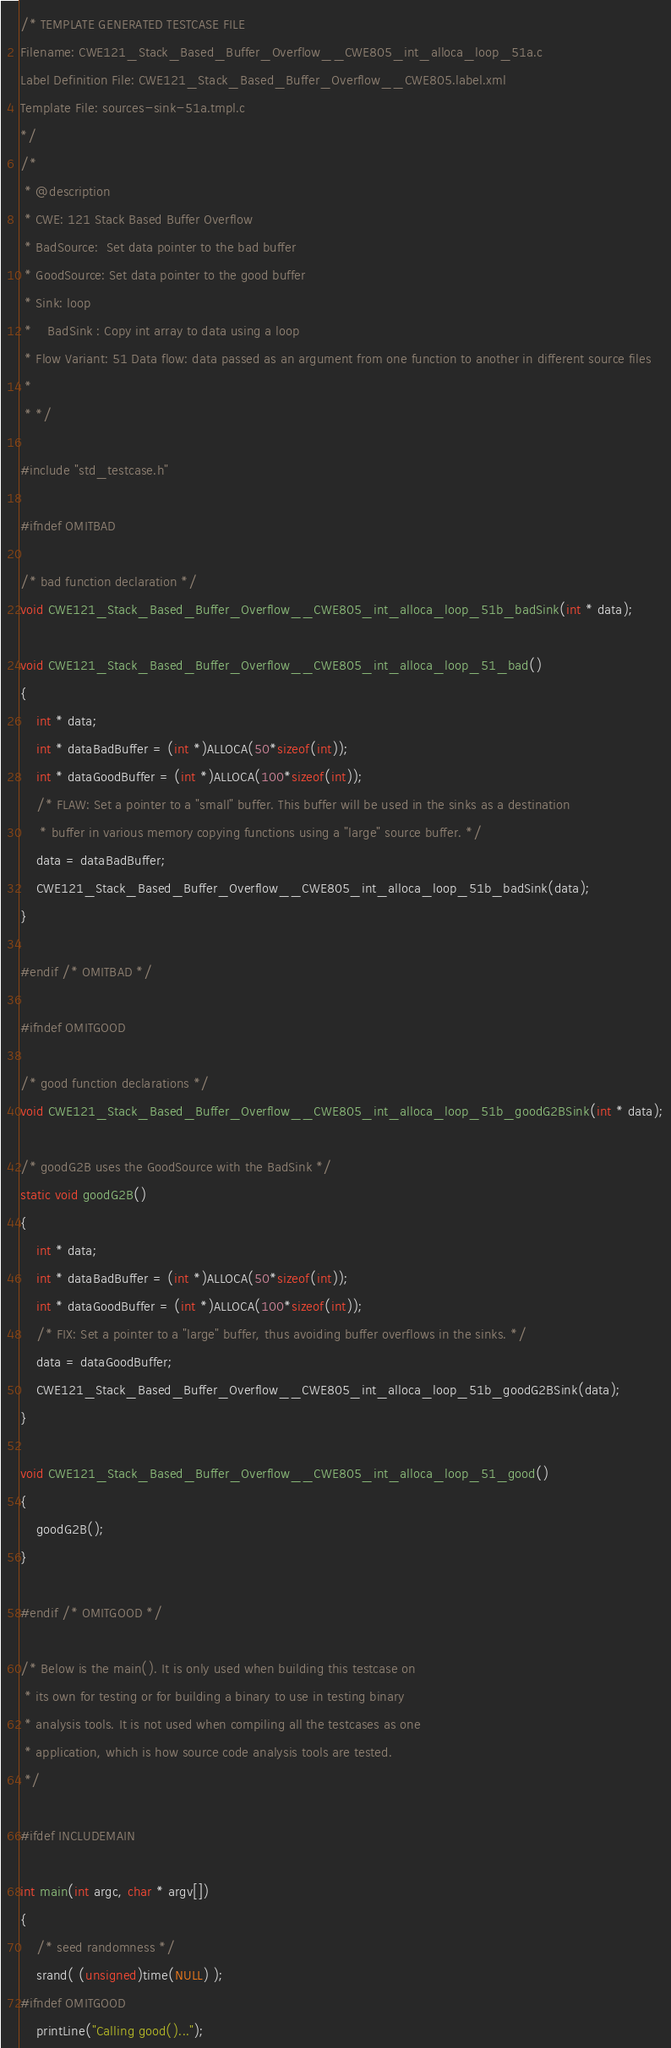Convert code to text. <code><loc_0><loc_0><loc_500><loc_500><_C_>/* TEMPLATE GENERATED TESTCASE FILE
Filename: CWE121_Stack_Based_Buffer_Overflow__CWE805_int_alloca_loop_51a.c
Label Definition File: CWE121_Stack_Based_Buffer_Overflow__CWE805.label.xml
Template File: sources-sink-51a.tmpl.c
*/
/*
 * @description
 * CWE: 121 Stack Based Buffer Overflow
 * BadSource:  Set data pointer to the bad buffer
 * GoodSource: Set data pointer to the good buffer
 * Sink: loop
 *    BadSink : Copy int array to data using a loop
 * Flow Variant: 51 Data flow: data passed as an argument from one function to another in different source files
 *
 * */

#include "std_testcase.h"

#ifndef OMITBAD

/* bad function declaration */
void CWE121_Stack_Based_Buffer_Overflow__CWE805_int_alloca_loop_51b_badSink(int * data);

void CWE121_Stack_Based_Buffer_Overflow__CWE805_int_alloca_loop_51_bad()
{
    int * data;
    int * dataBadBuffer = (int *)ALLOCA(50*sizeof(int));
    int * dataGoodBuffer = (int *)ALLOCA(100*sizeof(int));
    /* FLAW: Set a pointer to a "small" buffer. This buffer will be used in the sinks as a destination
     * buffer in various memory copying functions using a "large" source buffer. */
    data = dataBadBuffer;
    CWE121_Stack_Based_Buffer_Overflow__CWE805_int_alloca_loop_51b_badSink(data);
}

#endif /* OMITBAD */

#ifndef OMITGOOD

/* good function declarations */
void CWE121_Stack_Based_Buffer_Overflow__CWE805_int_alloca_loop_51b_goodG2BSink(int * data);

/* goodG2B uses the GoodSource with the BadSink */
static void goodG2B()
{
    int * data;
    int * dataBadBuffer = (int *)ALLOCA(50*sizeof(int));
    int * dataGoodBuffer = (int *)ALLOCA(100*sizeof(int));
    /* FIX: Set a pointer to a "large" buffer, thus avoiding buffer overflows in the sinks. */
    data = dataGoodBuffer;
    CWE121_Stack_Based_Buffer_Overflow__CWE805_int_alloca_loop_51b_goodG2BSink(data);
}

void CWE121_Stack_Based_Buffer_Overflow__CWE805_int_alloca_loop_51_good()
{
    goodG2B();
}

#endif /* OMITGOOD */

/* Below is the main(). It is only used when building this testcase on
 * its own for testing or for building a binary to use in testing binary
 * analysis tools. It is not used when compiling all the testcases as one
 * application, which is how source code analysis tools are tested.
 */

#ifdef INCLUDEMAIN

int main(int argc, char * argv[])
{
    /* seed randomness */
    srand( (unsigned)time(NULL) );
#ifndef OMITGOOD
    printLine("Calling good()...");</code> 